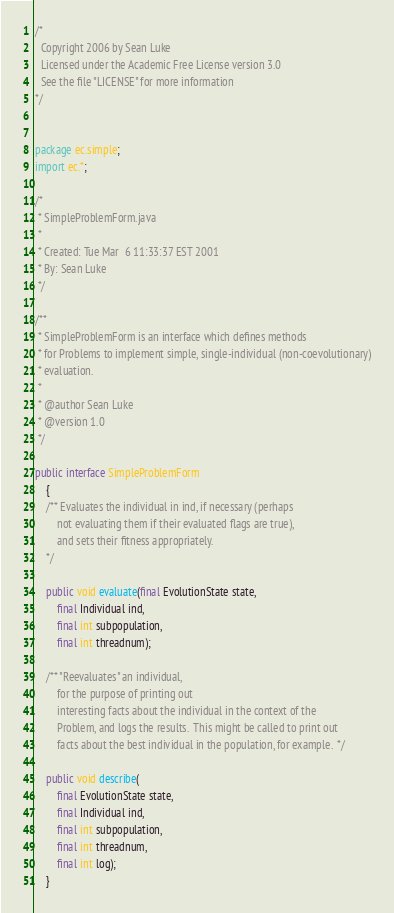Convert code to text. <code><loc_0><loc_0><loc_500><loc_500><_Java_>/*
  Copyright 2006 by Sean Luke
  Licensed under the Academic Free License version 3.0
  See the file "LICENSE" for more information
*/


package ec.simple;
import ec.*;

/* 
 * SimpleProblemForm.java
 * 
 * Created: Tue Mar  6 11:33:37 EST 2001
 * By: Sean Luke
 */

/**
 * SimpleProblemForm is an interface which defines methods
 * for Problems to implement simple, single-individual (non-coevolutionary)
 * evaluation.
 *
 * @author Sean Luke
 * @version 1.0 
 */

public interface SimpleProblemForm
    {
    /** Evaluates the individual in ind, if necessary (perhaps
        not evaluating them if their evaluated flags are true),
        and sets their fitness appropriately. 
    */

    public void evaluate(final EvolutionState state,
        final Individual ind,
        final int subpopulation,
        final int threadnum);

    /** "Reevaluates" an individual,
        for the purpose of printing out
        interesting facts about the individual in the context of the
        Problem, and logs the results.  This might be called to print out 
        facts about the best individual in the population, for example.  */
    
    public void describe(
        final EvolutionState state, 
        final Individual ind, 
        final int subpopulation,
        final int threadnum,
        final int log);
    }
</code> 